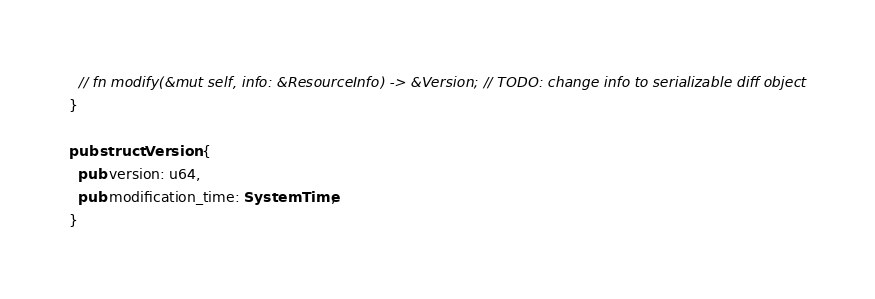<code> <loc_0><loc_0><loc_500><loc_500><_Rust_>  // fn modify(&mut self, info: &ResourceInfo) -> &Version; // TODO: change info to serializable diff object
}

pub struct Version {
  pub version: u64,
  pub modification_time: SystemTime,
}</code> 